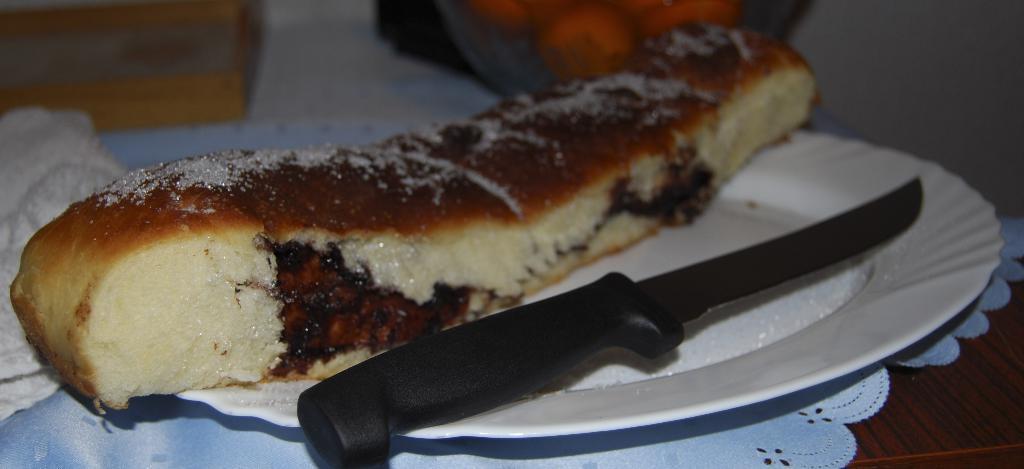Describe this image in one or two sentences. In this picture we can see a plate with a knife, food on it, white cloth on a wooden surface and in the background we can see some objects. 